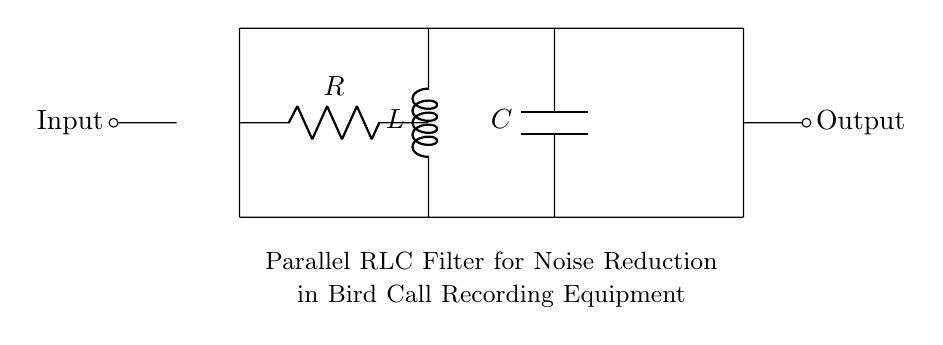What type of components are used in this circuit? The components seen in the circuit diagram include a resistor, an inductor, and a capacitor, which are the essential elements for a parallel RLC filter.
Answer: Resistor, inductor, capacitor What is the configuration of the RLC components in the circuit? The RLC components are connected in parallel, as indicated by the horizontal alignment of the resistor, inductor, and capacitor, sharing both terminals.
Answer: Parallel How many input and output connections does this circuit have? The circuit has one input connection on the left and one output connection on the right, represented by the short lines leading to the labels "Input" and "Output".
Answer: Two What is the purpose of this circuit? The circuit is designed to filter noise, specifically for bird call recording equipment, as stated in the description below the circuit diagram.
Answer: Noise reduction Which component is responsible for opposing changes in current? The inductor is responsible for opposing changes in current due to its property of inductance, which stores energy in a magnetic field.
Answer: Inductor What role does the capacitor play in this circuit? The capacitor plays the role of storing and releasing energy, which helps smooth out voltage fluctuations and filter noise from the input signals.
Answer: Energy storage What would happen if one of the components is removed? Removing any component, such as the resistor, inductor, or capacitor, would disrupt the filtering effect of the circuit, potentially allowing more noise through.
Answer: Disrupt filtering 